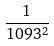<formula> <loc_0><loc_0><loc_500><loc_500>\frac { 1 } { 1 0 9 3 ^ { 2 } }</formula> 